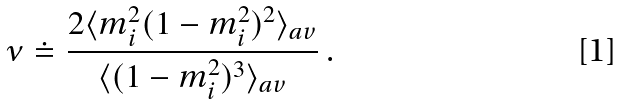<formula> <loc_0><loc_0><loc_500><loc_500>\nu \doteq \frac { 2 \langle m _ { i } ^ { 2 } ( 1 - m _ { i } ^ { 2 } ) ^ { 2 } \rangle _ { a v } } { \langle ( 1 - m _ { i } ^ { 2 } ) ^ { 3 } \rangle _ { a v } } \ .</formula> 